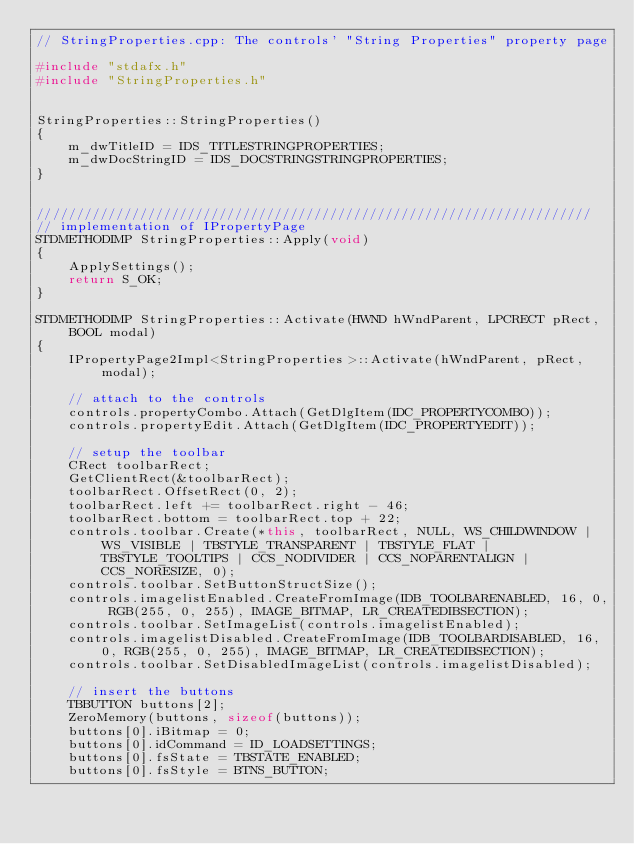<code> <loc_0><loc_0><loc_500><loc_500><_C++_>// StringProperties.cpp: The controls' "String Properties" property page

#include "stdafx.h"
#include "StringProperties.h"


StringProperties::StringProperties()
{
	m_dwTitleID = IDS_TITLESTRINGPROPERTIES;
	m_dwDocStringID = IDS_DOCSTRINGSTRINGPROPERTIES;
}


//////////////////////////////////////////////////////////////////////
// implementation of IPropertyPage
STDMETHODIMP StringProperties::Apply(void)
{
	ApplySettings();
	return S_OK;
}

STDMETHODIMP StringProperties::Activate(HWND hWndParent, LPCRECT pRect, BOOL modal)
{
	IPropertyPage2Impl<StringProperties>::Activate(hWndParent, pRect, modal);

	// attach to the controls
	controls.propertyCombo.Attach(GetDlgItem(IDC_PROPERTYCOMBO));
	controls.propertyEdit.Attach(GetDlgItem(IDC_PROPERTYEDIT));

	// setup the toolbar
	CRect toolbarRect;
	GetClientRect(&toolbarRect);
	toolbarRect.OffsetRect(0, 2);
	toolbarRect.left += toolbarRect.right - 46;
	toolbarRect.bottom = toolbarRect.top + 22;
	controls.toolbar.Create(*this, toolbarRect, NULL, WS_CHILDWINDOW | WS_VISIBLE | TBSTYLE_TRANSPARENT | TBSTYLE_FLAT | TBSTYLE_TOOLTIPS | CCS_NODIVIDER | CCS_NOPARENTALIGN | CCS_NORESIZE, 0);
	controls.toolbar.SetButtonStructSize();
	controls.imagelistEnabled.CreateFromImage(IDB_TOOLBARENABLED, 16, 0, RGB(255, 0, 255), IMAGE_BITMAP, LR_CREATEDIBSECTION);
	controls.toolbar.SetImageList(controls.imagelistEnabled);
	controls.imagelistDisabled.CreateFromImage(IDB_TOOLBARDISABLED, 16, 0, RGB(255, 0, 255), IMAGE_BITMAP, LR_CREATEDIBSECTION);
	controls.toolbar.SetDisabledImageList(controls.imagelistDisabled);

	// insert the buttons
	TBBUTTON buttons[2];
	ZeroMemory(buttons, sizeof(buttons));
	buttons[0].iBitmap = 0;
	buttons[0].idCommand = ID_LOADSETTINGS;
	buttons[0].fsState = TBSTATE_ENABLED;
	buttons[0].fsStyle = BTNS_BUTTON;</code> 